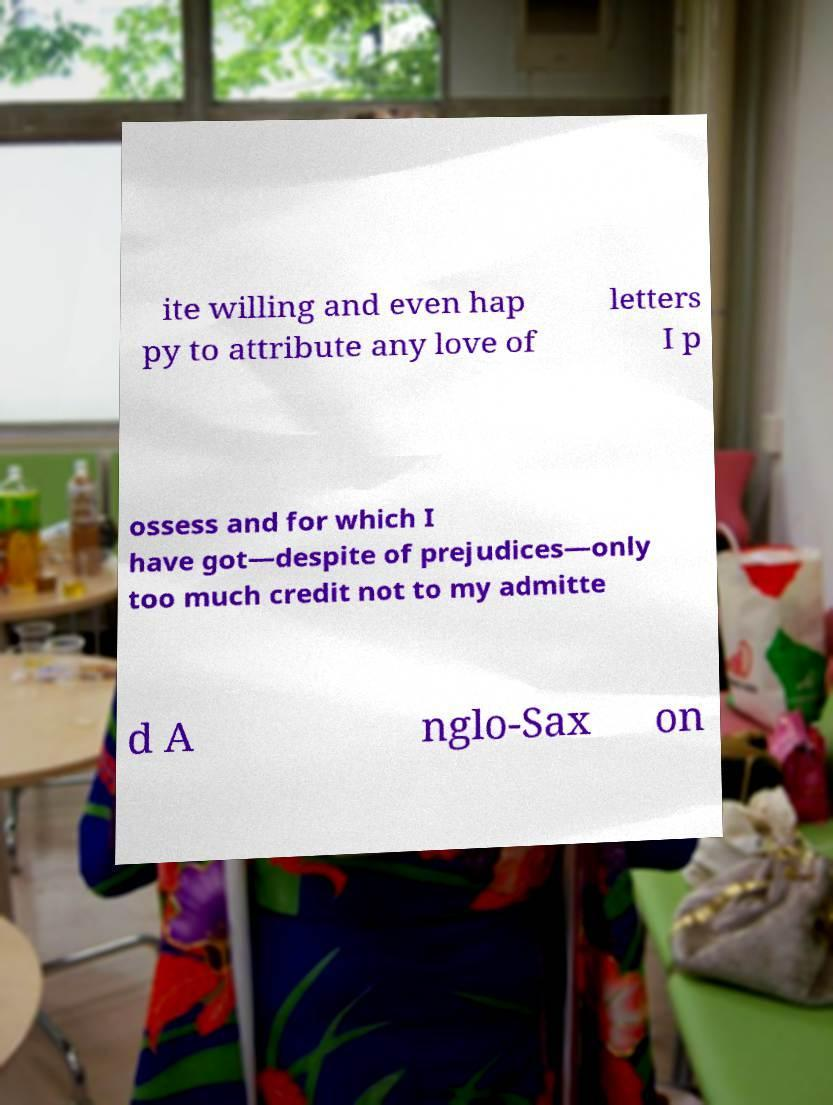For documentation purposes, I need the text within this image transcribed. Could you provide that? ite willing and even hap py to attribute any love of letters I p ossess and for which I have got—despite of prejudices—only too much credit not to my admitte d A nglo-Sax on 